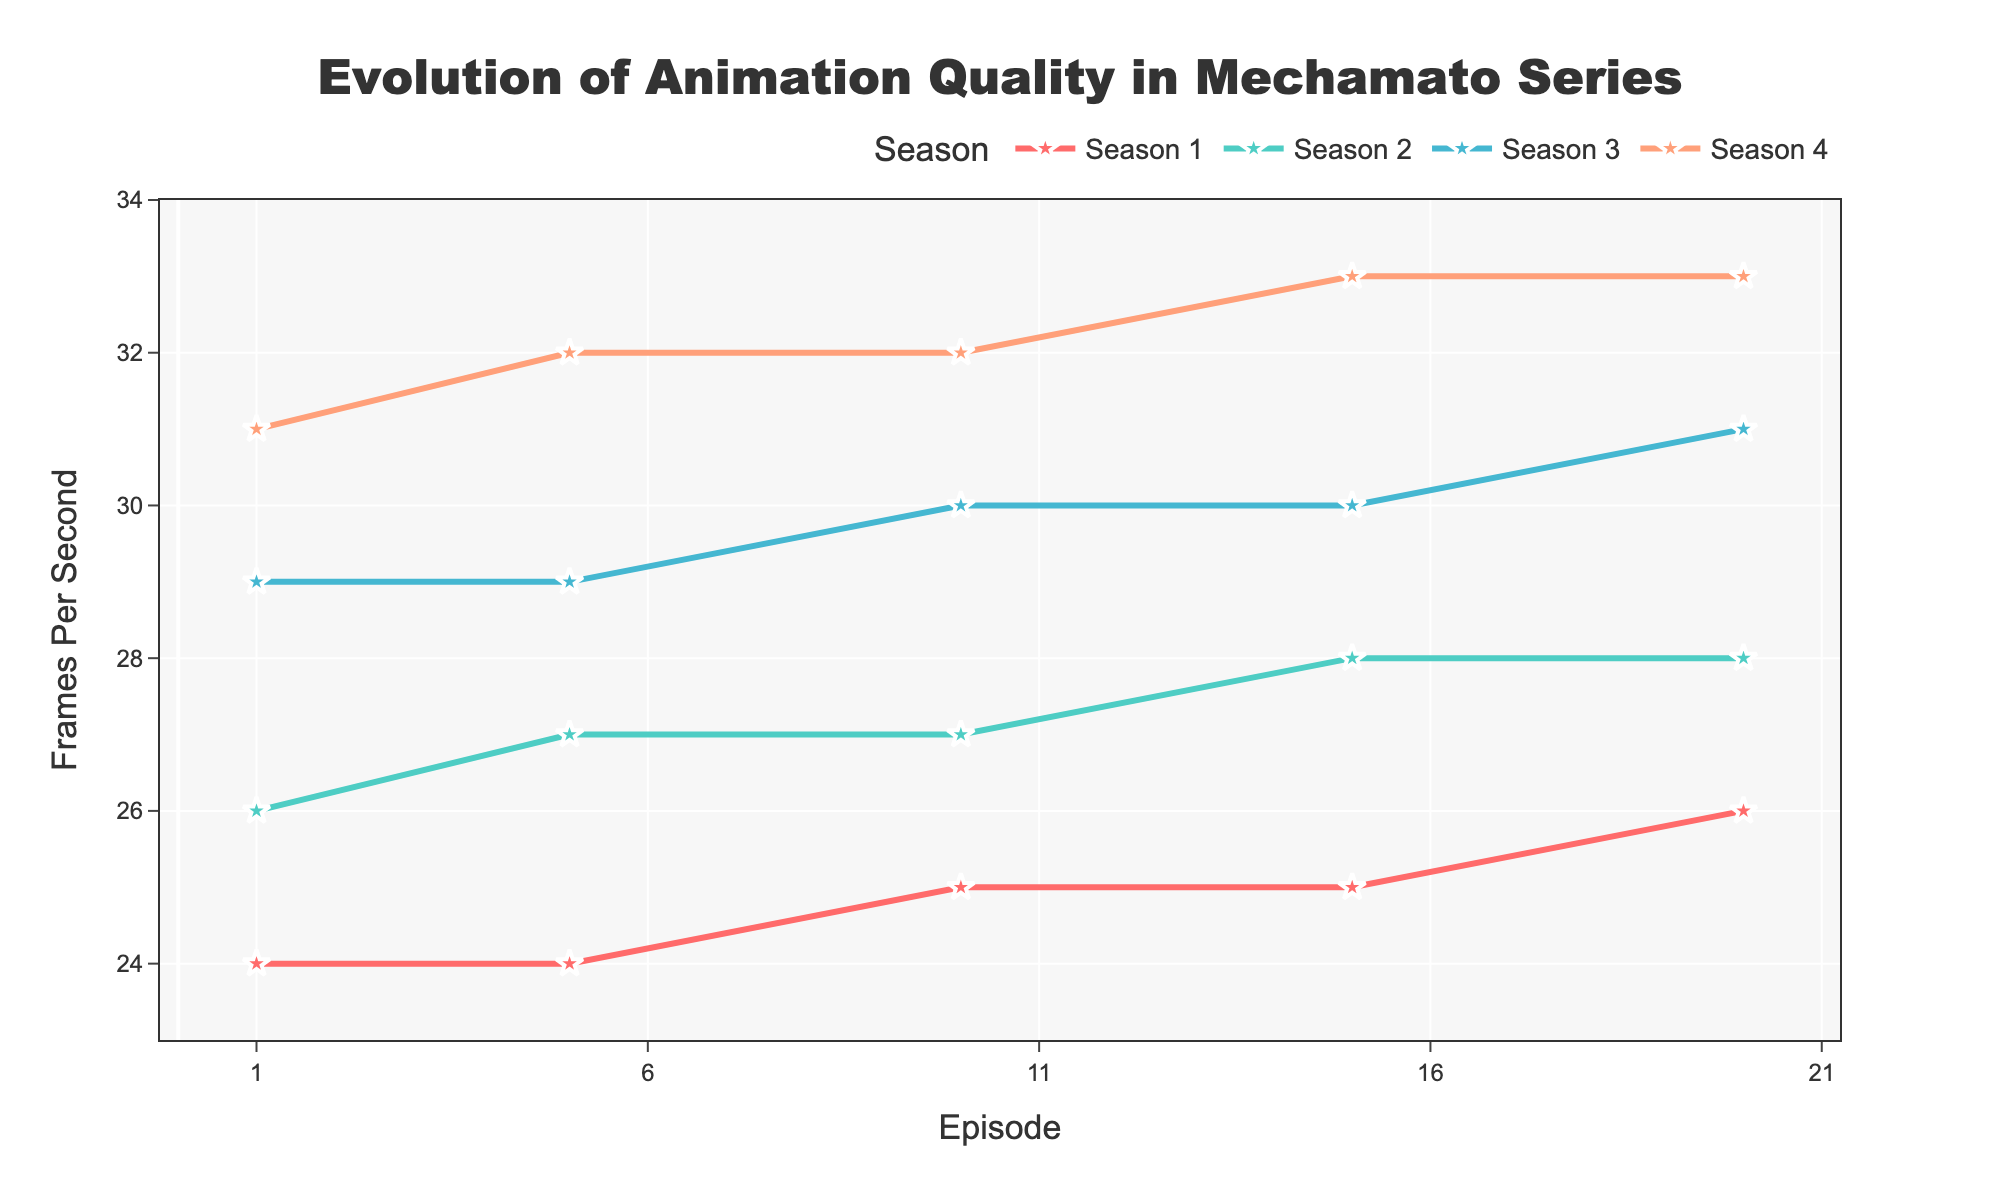Which season has the highest frames per second at any episode? By observing the highest point on the y-axis which reaches 33 frames per second at the last episode of Season 4, it is evident that Season 4 contains the highest FPS in any episode.
Answer: Season 4 What is the increase in frames per second from the first episode of Season 1 to the last episode of Season 4? The first episode of Season 1 has 24 FPS and the last episode of Season 4 has 33 FPS. The increase is calculated as 33 - 24 = 9 FPS.
Answer: 9 FPS How do the frames per second in the first episodes of Seasons 1 and 2 compare? Comparing the points at the first episodes of Seasons 1 (with 24 FPS) and 2 (with 26 FPS), Season 2 has 2 more FPS than Season 1 for the first episode.
Answer: 2 FPS more Which season shows the most sudden increase in frames per second within a short number of episodes? Observing the steepness of the lines, between Season 2 and 3, especially from the last episode of Season 2 (28 FPS) to the first episode of Season 3 (29 FPS), there is a noticeable 1 FPS increase which is consistent but not as sudden compared to other seasons. While there are gradual increases in all seasons, Season 4 demonstrates a smooth increase rather than a sudden rise.
Answer: Season 4 What is the average frames per second in Season 1? The frames per second for episodes in Season 1 are 24, 24, 25, 25, 26. Summing these gives 24+24+25+25+26 = 124. Dividing by the number of episodes, 124 / 5 = 24.8 FPS.
Answer: 24.8 FPS Which season has the smallest improvement in frames per second from the start to end? By evaluating the start and end points of each season, Season 1 starts at 24 FPS and ends at 26 FPS (2 FPS increase), Season 2 goes from 26 FPS to 28 FPS (2 FPS), Season 3 from 29 FPS to 31 FPS (2 FPS), Season 4 from 31 FPS to 33 FPS (2 FPS). All seasons have a consistent improvement, and thus the smallest improvement is the same for all, being 2 FPS.
Answer: All seasons at 2 FPS What is the FPS difference between the start of Season 2 and the end of Season 3? The first episode of Season 2 has 26 FPS, and the last episode of Season 3 has 31 FPS. The difference is 31 - 26 = 5 FPS.
Answer: 5 FPS What color is used to represent Season 3 in the plot? The lines and markers for Season 3 are visualized using a specific color which can be identified from the legend as a set light blue to differentiate from other seasons.
Answer: Light blue In which season does the frames per second consistently increase with every episode? By tracing the slope from episode to episode, Season 4 shows a consistent increase in FPS with no plateaus or dips, thus continuously progressing from 31 to 33 FPS.
Answer: Season 4 